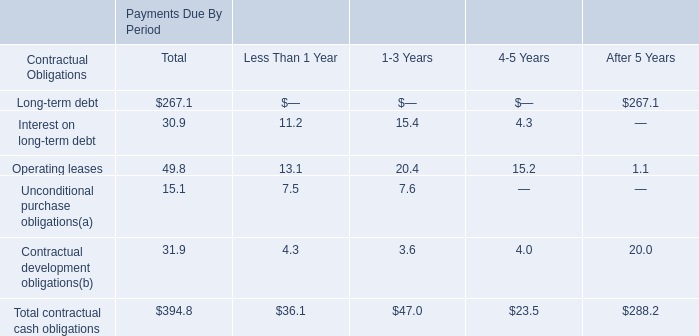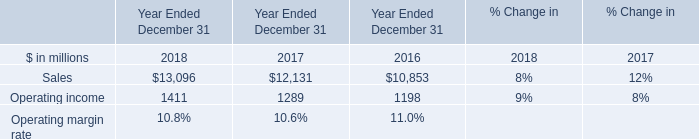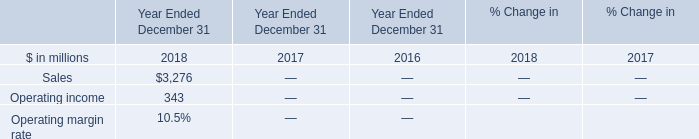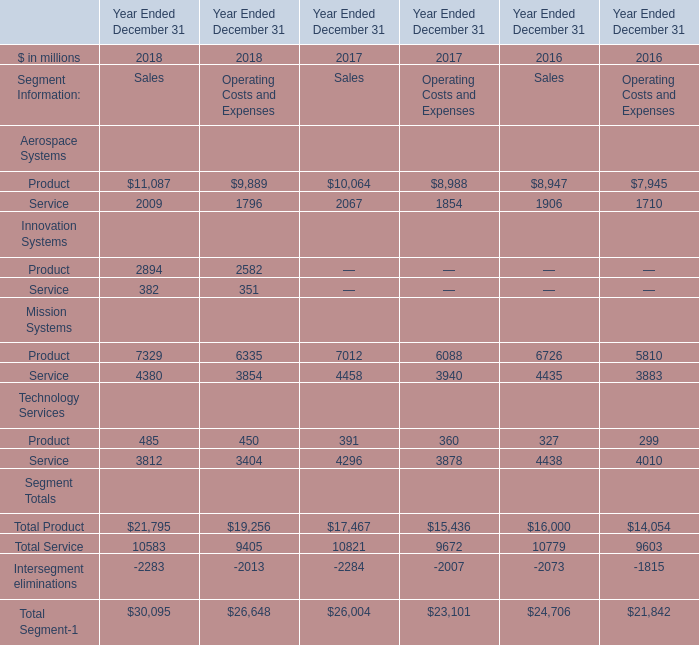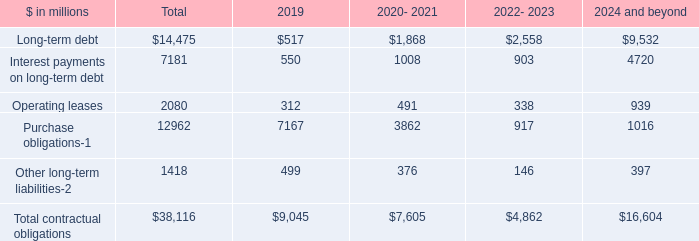What is the sum of Total Product, Total Service and Intersegment eliminations in 2018? (in million) 
Computations: ((21795 + 10583) - 2283)
Answer: 30095.0. 